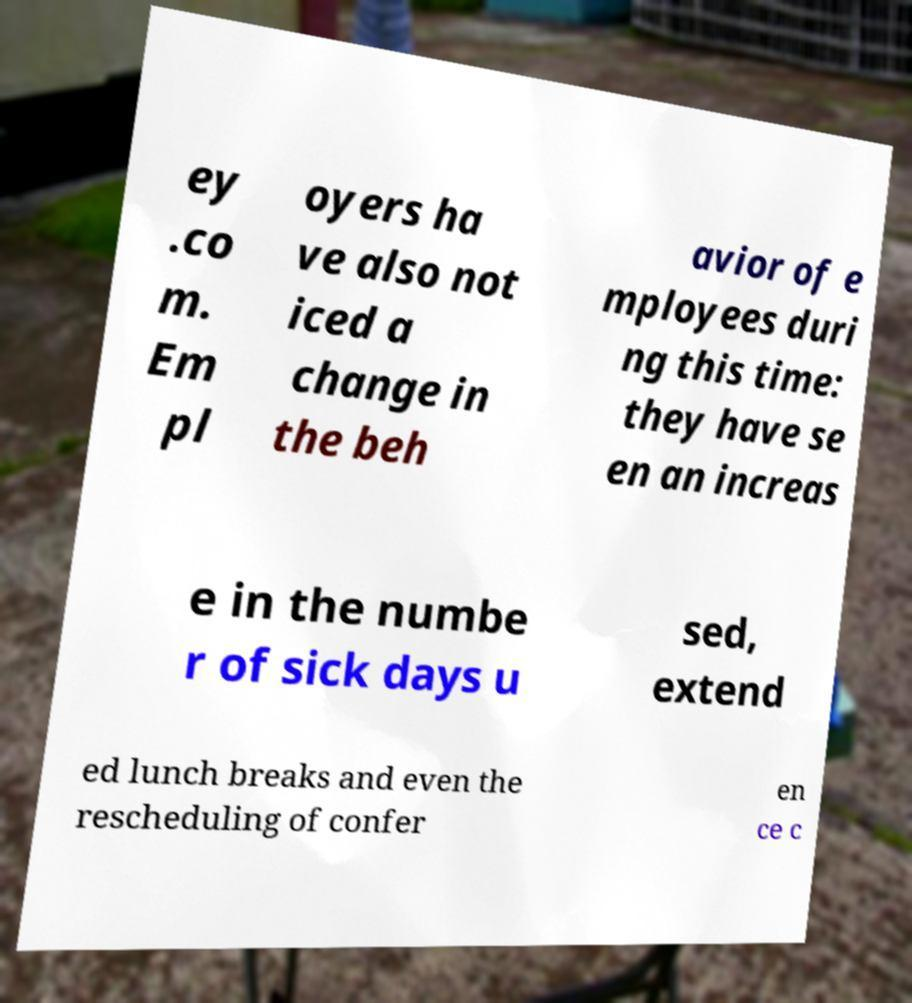Can you accurately transcribe the text from the provided image for me? ey .co m. Em pl oyers ha ve also not iced a change in the beh avior of e mployees duri ng this time: they have se en an increas e in the numbe r of sick days u sed, extend ed lunch breaks and even the rescheduling of confer en ce c 